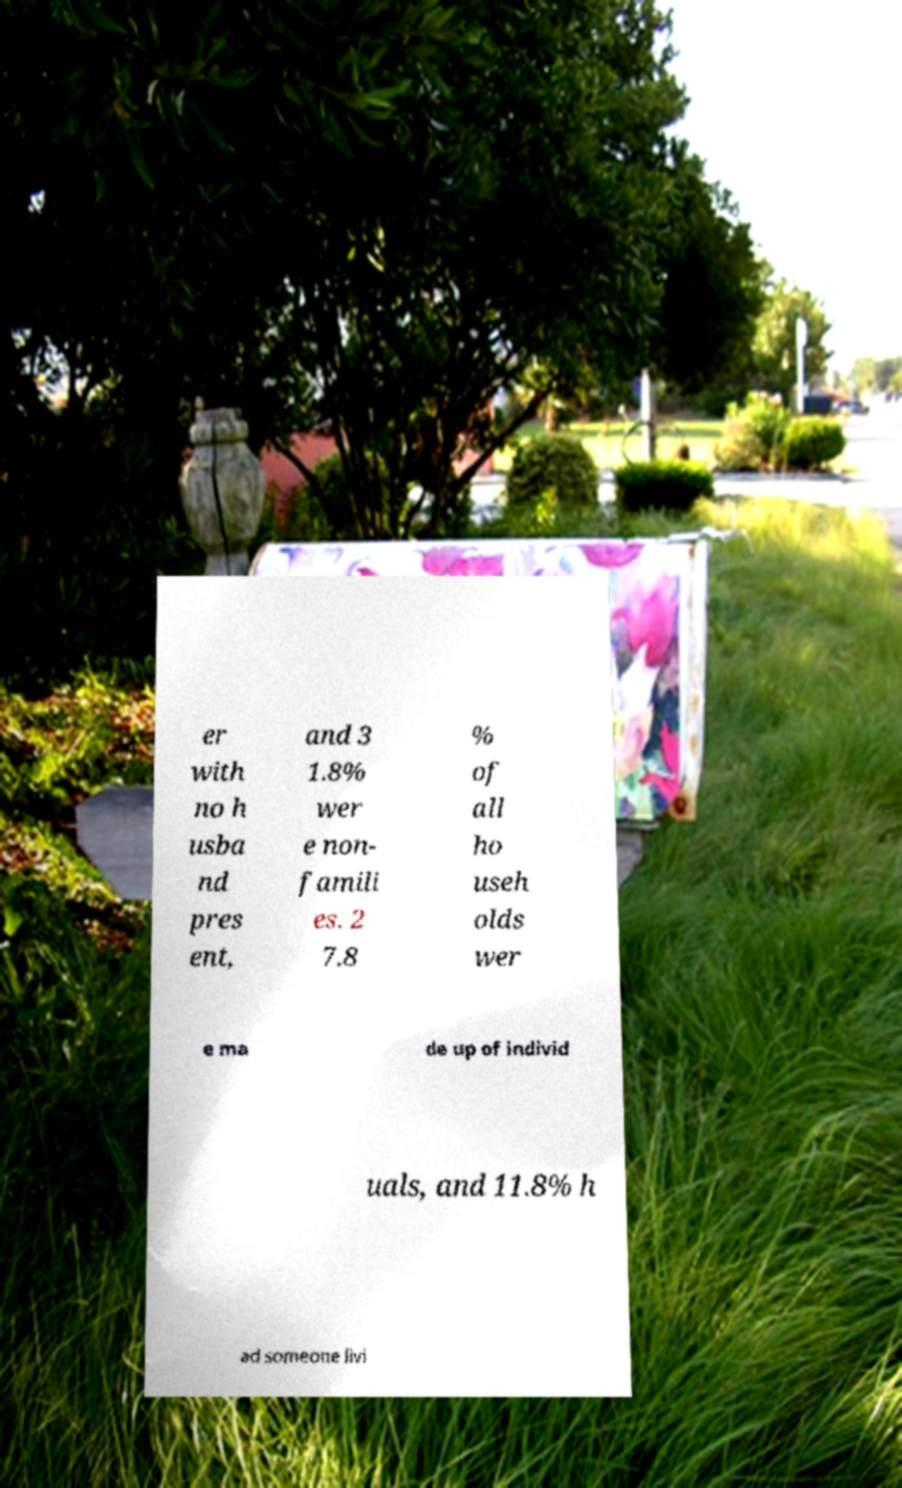Can you accurately transcribe the text from the provided image for me? er with no h usba nd pres ent, and 3 1.8% wer e non- famili es. 2 7.8 % of all ho useh olds wer e ma de up of individ uals, and 11.8% h ad someone livi 